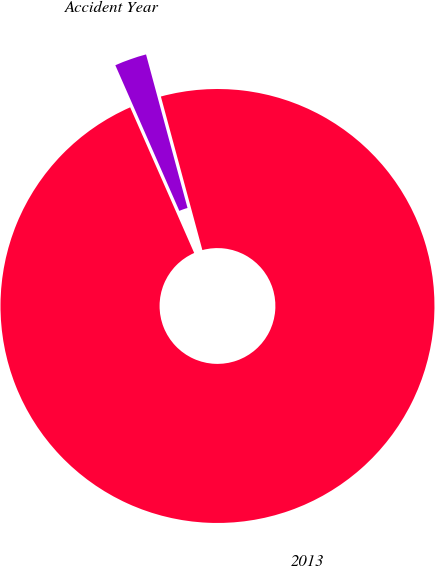<chart> <loc_0><loc_0><loc_500><loc_500><pie_chart><fcel>Accident Year<fcel>2013<nl><fcel>2.39%<fcel>97.61%<nl></chart> 